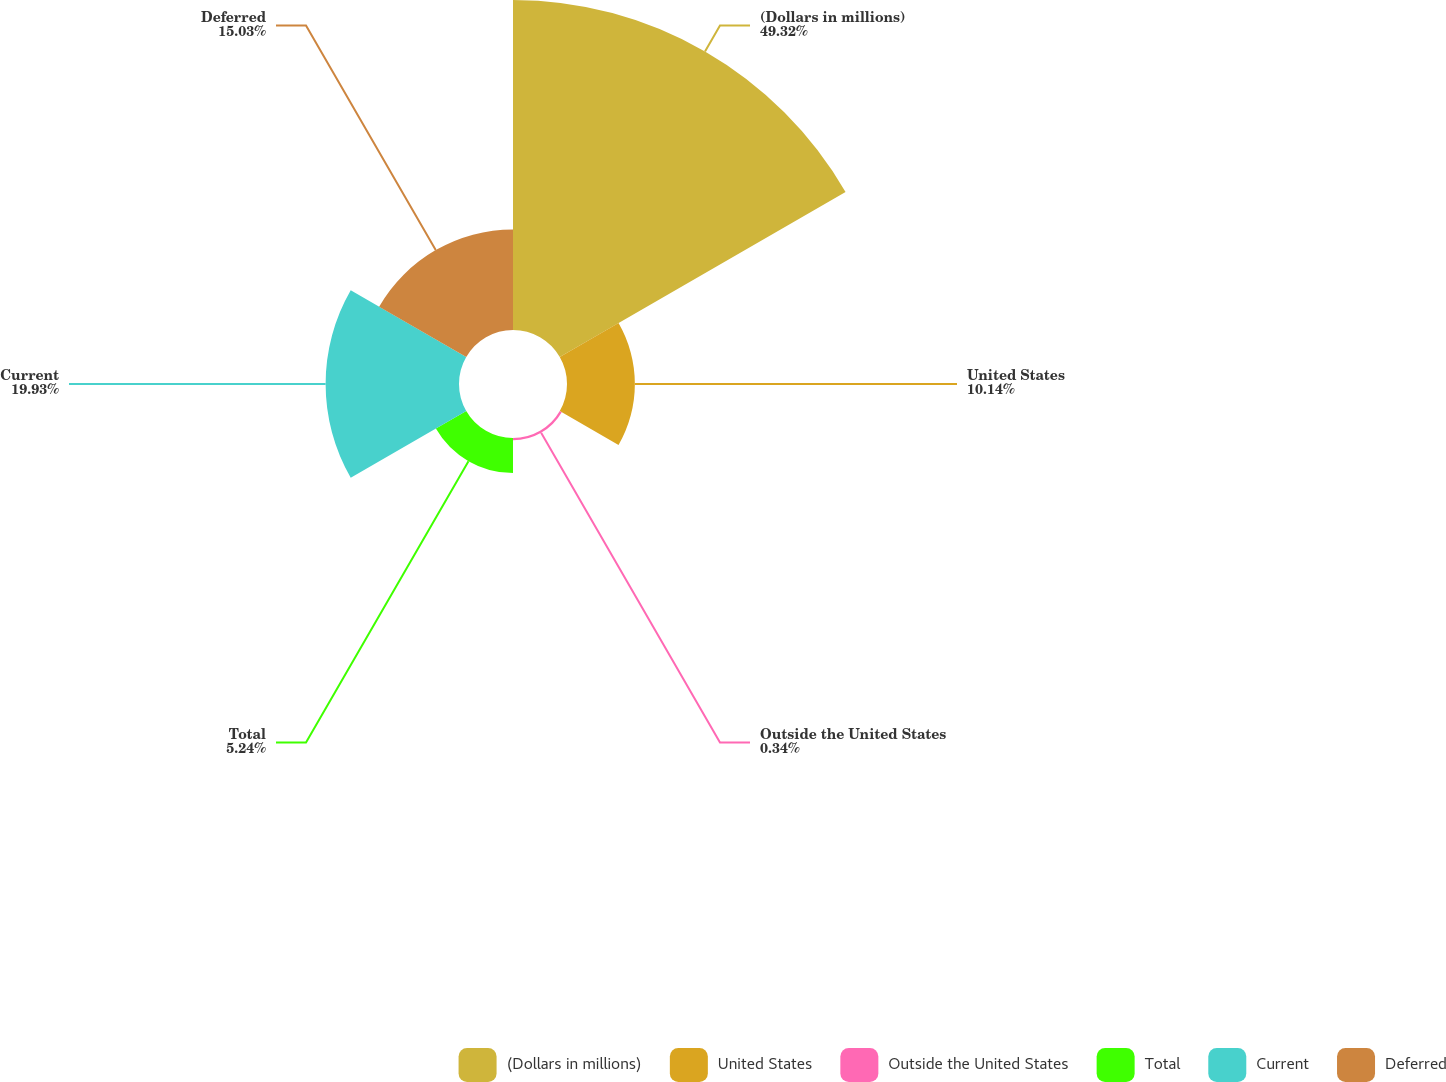<chart> <loc_0><loc_0><loc_500><loc_500><pie_chart><fcel>(Dollars in millions)<fcel>United States<fcel>Outside the United States<fcel>Total<fcel>Current<fcel>Deferred<nl><fcel>49.31%<fcel>10.14%<fcel>0.34%<fcel>5.24%<fcel>19.93%<fcel>15.03%<nl></chart> 